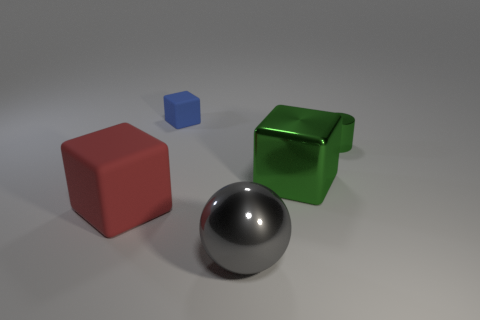Subtract all big red rubber cubes. How many cubes are left? 2 Add 4 large balls. How many objects exist? 9 Subtract all blue blocks. How many blocks are left? 2 Subtract all cubes. How many objects are left? 2 Add 1 big red matte things. How many big red matte things are left? 2 Add 2 small red rubber balls. How many small red rubber balls exist? 2 Subtract 0 blue cylinders. How many objects are left? 5 Subtract all cyan cubes. Subtract all blue cylinders. How many cubes are left? 3 Subtract all cylinders. Subtract all big rubber things. How many objects are left? 3 